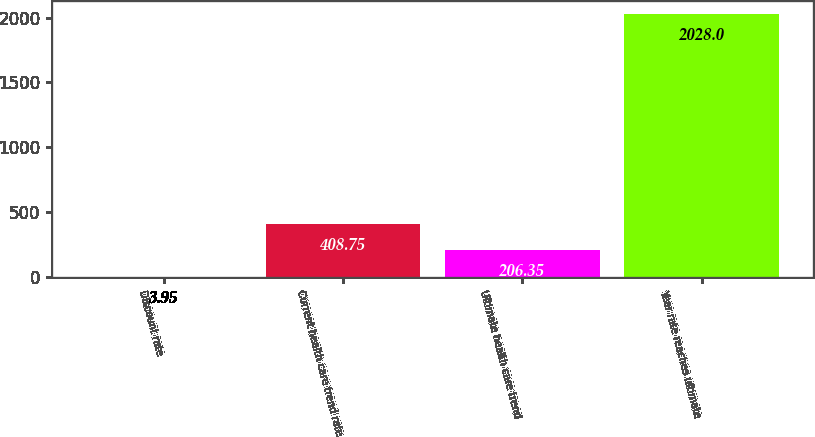<chart> <loc_0><loc_0><loc_500><loc_500><bar_chart><fcel>Discount rate<fcel>Current health care trend rate<fcel>Ultimate health care trend<fcel>Year rate reaches ultimate<nl><fcel>3.95<fcel>408.75<fcel>206.35<fcel>2028<nl></chart> 